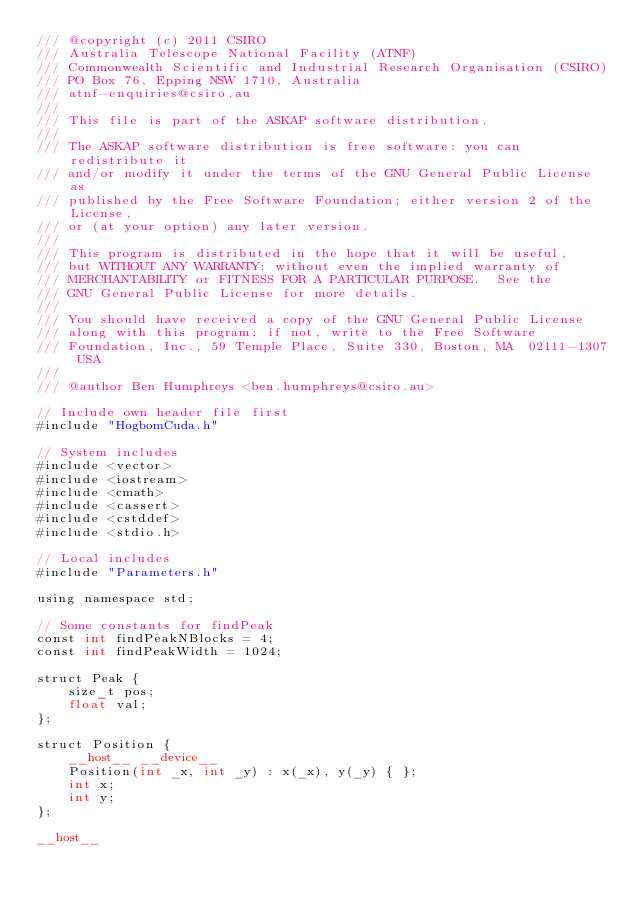<code> <loc_0><loc_0><loc_500><loc_500><_Cuda_>/// @copyright (c) 2011 CSIRO
/// Australia Telescope National Facility (ATNF)
/// Commonwealth Scientific and Industrial Research Organisation (CSIRO)
/// PO Box 76, Epping NSW 1710, Australia
/// atnf-enquiries@csiro.au
///
/// This file is part of the ASKAP software distribution.
///
/// The ASKAP software distribution is free software: you can redistribute it
/// and/or modify it under the terms of the GNU General Public License as
/// published by the Free Software Foundation; either version 2 of the License,
/// or (at your option) any later version.
///
/// This program is distributed in the hope that it will be useful,
/// but WITHOUT ANY WARRANTY; without even the implied warranty of
/// MERCHANTABILITY or FITNESS FOR A PARTICULAR PURPOSE.  See the
/// GNU General Public License for more details.
///
/// You should have received a copy of the GNU General Public License
/// along with this program; if not, write to the Free Software
/// Foundation, Inc., 59 Temple Place, Suite 330, Boston, MA  02111-1307 USA
///
/// @author Ben Humphreys <ben.humphreys@csiro.au>

// Include own header file first
#include "HogbomCuda.h"

// System includes
#include <vector>
#include <iostream>
#include <cmath>
#include <cassert>
#include <cstddef>
#include <stdio.h>

// Local includes
#include "Parameters.h"

using namespace std;

// Some constants for findPeak
const int findPeakNBlocks = 4;
const int findPeakWidth = 1024;

struct Peak {
    size_t pos;
    float val;
};

struct Position {
    __host__ __device__
    Position(int _x, int _y) : x(_x), y(_y) { };
    int x;
    int y;
};

__host__</code> 